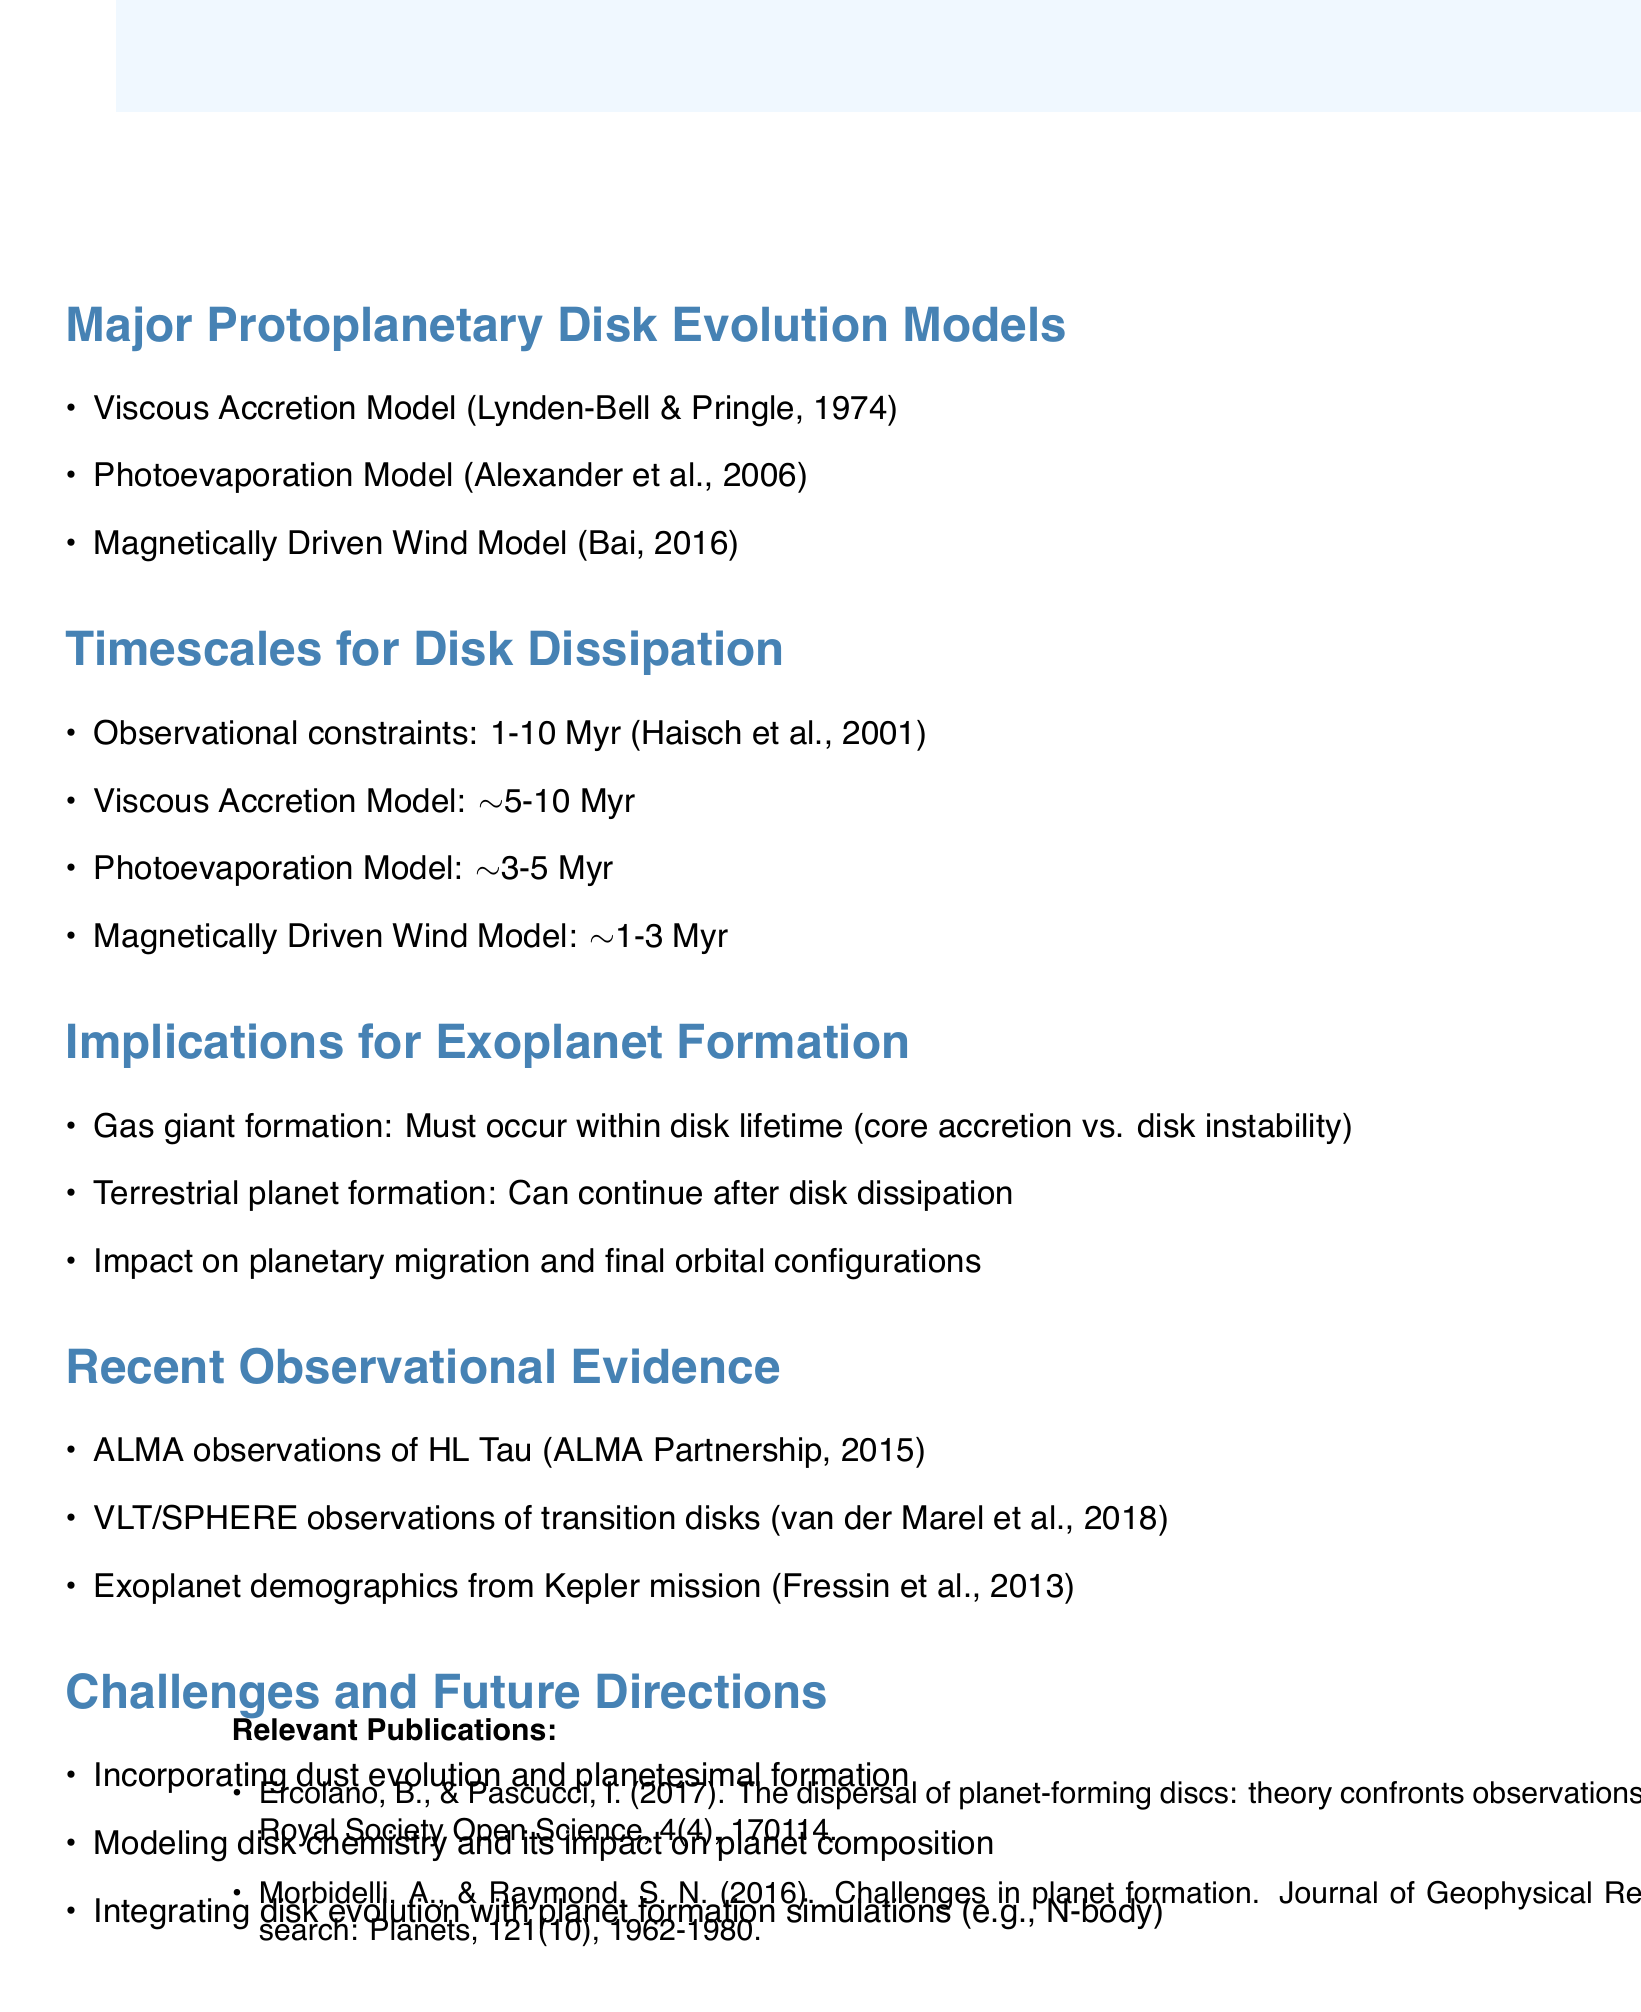What are the three major protoplanetary disk evolution models? The document lists the major models which include the Viscous Accretion Model, Photoevaporation Model, and Magnetically Driven Wind Model.
Answer: Viscous Accretion Model, Photoevaporation Model, Magnetically Driven Wind Model What is the timescale for the Photoevaporation Model? The document specifies that the timescale for the Photoevaporation Model is approximately 3 to 5 million years.
Answer: ~3-5 Myr Which observational evidence supports protoplanetary disk models? The document mentions ALMA observations of HL Tau as supporting evidence for disk models.
Answer: ALMA observations of HL Tau What is a challenge mentioned for future protoplanetary disk modeling? The document identifies incorporating dust evolution and planetesimal formation as a challenge for future modeling efforts.
Answer: Incorporating dust evolution and planetesimal formation Why must gas giant formation occur within the disk's lifetime? The document explains this is crucial for gas giant formation due to the differences between core accretion and disk instability processes.
Answer: Core accretion vs. disk instability Which publication discusses challenges in planet formation? The document cites Morbidelli and Raymond's work on challenges in planet formation.
Answer: Morbidelli, A., & Raymond, S. N. (2016) How long must gas giant formation take place according to the implications section? The implications section indicates that gas giant formation must occur within the disk's lifetime, which is generally a few million years.
Answer: Within disk lifetime What observational method was used to study transition disks? The document notes that VLT/SPHERE observations were utilized to investigate transition disks.
Answer: VLT/SPHERE observations 